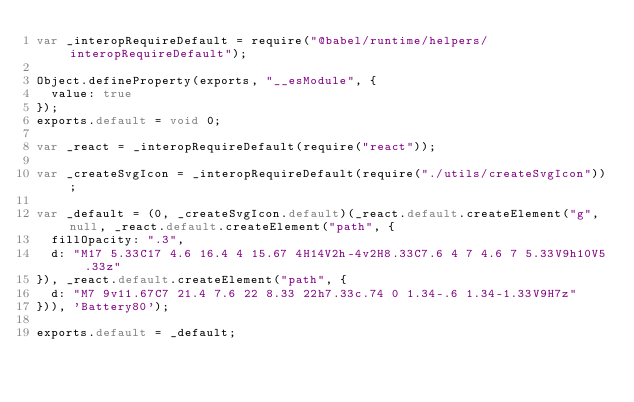<code> <loc_0><loc_0><loc_500><loc_500><_JavaScript_>var _interopRequireDefault = require("@babel/runtime/helpers/interopRequireDefault");

Object.defineProperty(exports, "__esModule", {
  value: true
});
exports.default = void 0;

var _react = _interopRequireDefault(require("react"));

var _createSvgIcon = _interopRequireDefault(require("./utils/createSvgIcon"));

var _default = (0, _createSvgIcon.default)(_react.default.createElement("g", null, _react.default.createElement("path", {
  fillOpacity: ".3",
  d: "M17 5.33C17 4.6 16.4 4 15.67 4H14V2h-4v2H8.33C7.6 4 7 4.6 7 5.33V9h10V5.33z"
}), _react.default.createElement("path", {
  d: "M7 9v11.67C7 21.4 7.6 22 8.33 22h7.33c.74 0 1.34-.6 1.34-1.33V9H7z"
})), 'Battery80');

exports.default = _default;</code> 